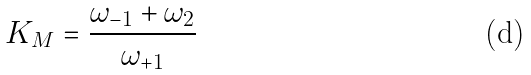Convert formula to latex. <formula><loc_0><loc_0><loc_500><loc_500>K _ { M } = \frac { \omega _ { - 1 } + \omega _ { 2 } } { \omega _ { + 1 } }</formula> 